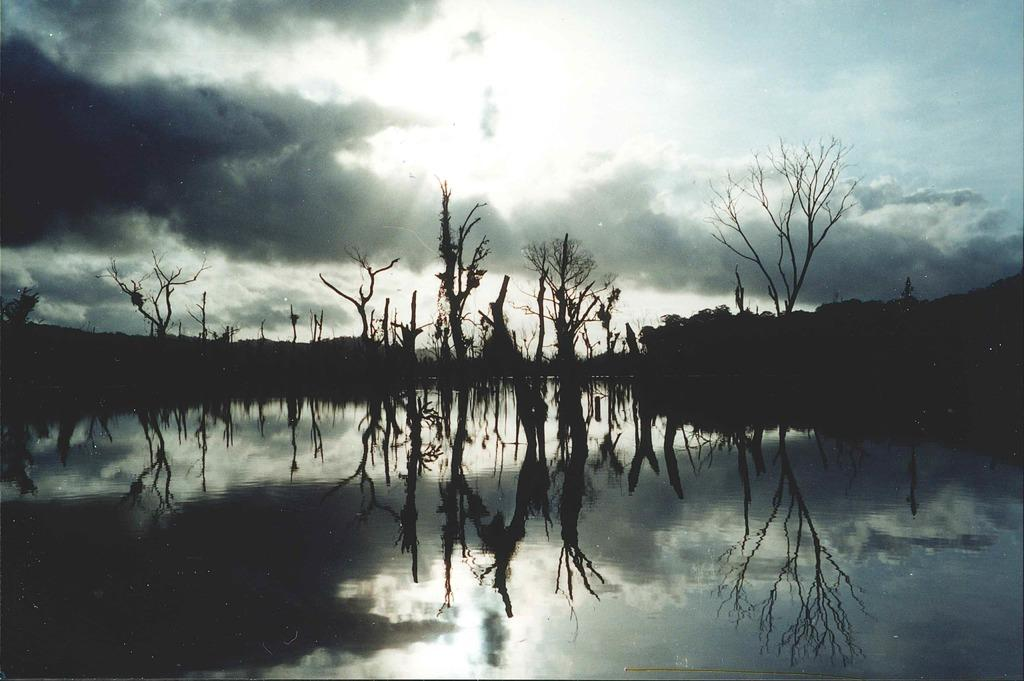What type of body of water is visible in the image? There is a lake in the image. What can be seen in the middle of the image? There are dry trees in the middle of the image. What is visible in the sky in the image? There are clouds in the sky. Where is the brother standing in the image? There is no brother present in the image. What type of lamp is illuminating the dry trees in the image? There is no lamp present in the image; the dry trees are in natural light. 